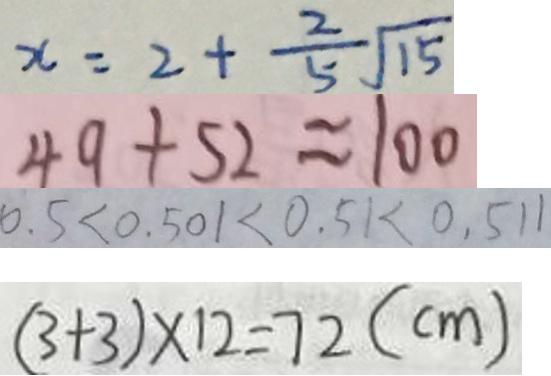Convert formula to latex. <formula><loc_0><loc_0><loc_500><loc_500>x = 2 + \frac { 2 } { 5 } \sqrt { 1 5 } 
 4 9 + 5 2 \approx 1 0 0 
 0 . 5 < 0 . 5 0 1 < 0 . 5 1 < 0 . 5 1 1 
 ( 3 + 3 ) \times 1 2 = 7 2 ( c m )</formula> 